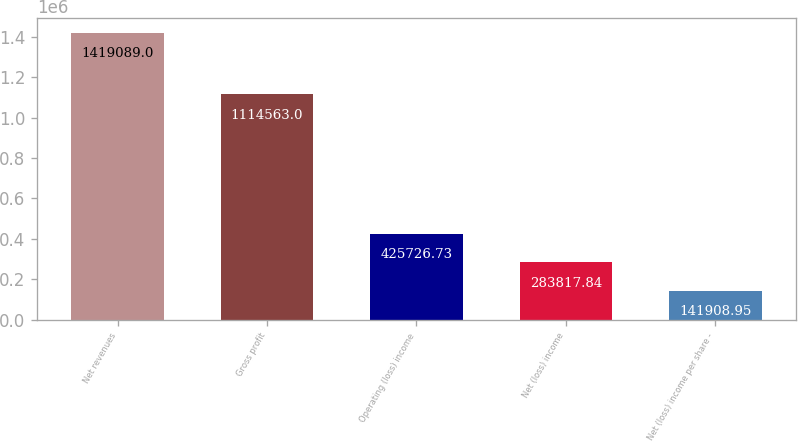Convert chart. <chart><loc_0><loc_0><loc_500><loc_500><bar_chart><fcel>Net revenues<fcel>Gross profit<fcel>Operating (loss) income<fcel>Net (loss) income<fcel>Net (loss) income per share -<nl><fcel>1.41909e+06<fcel>1.11456e+06<fcel>425727<fcel>283818<fcel>141909<nl></chart> 